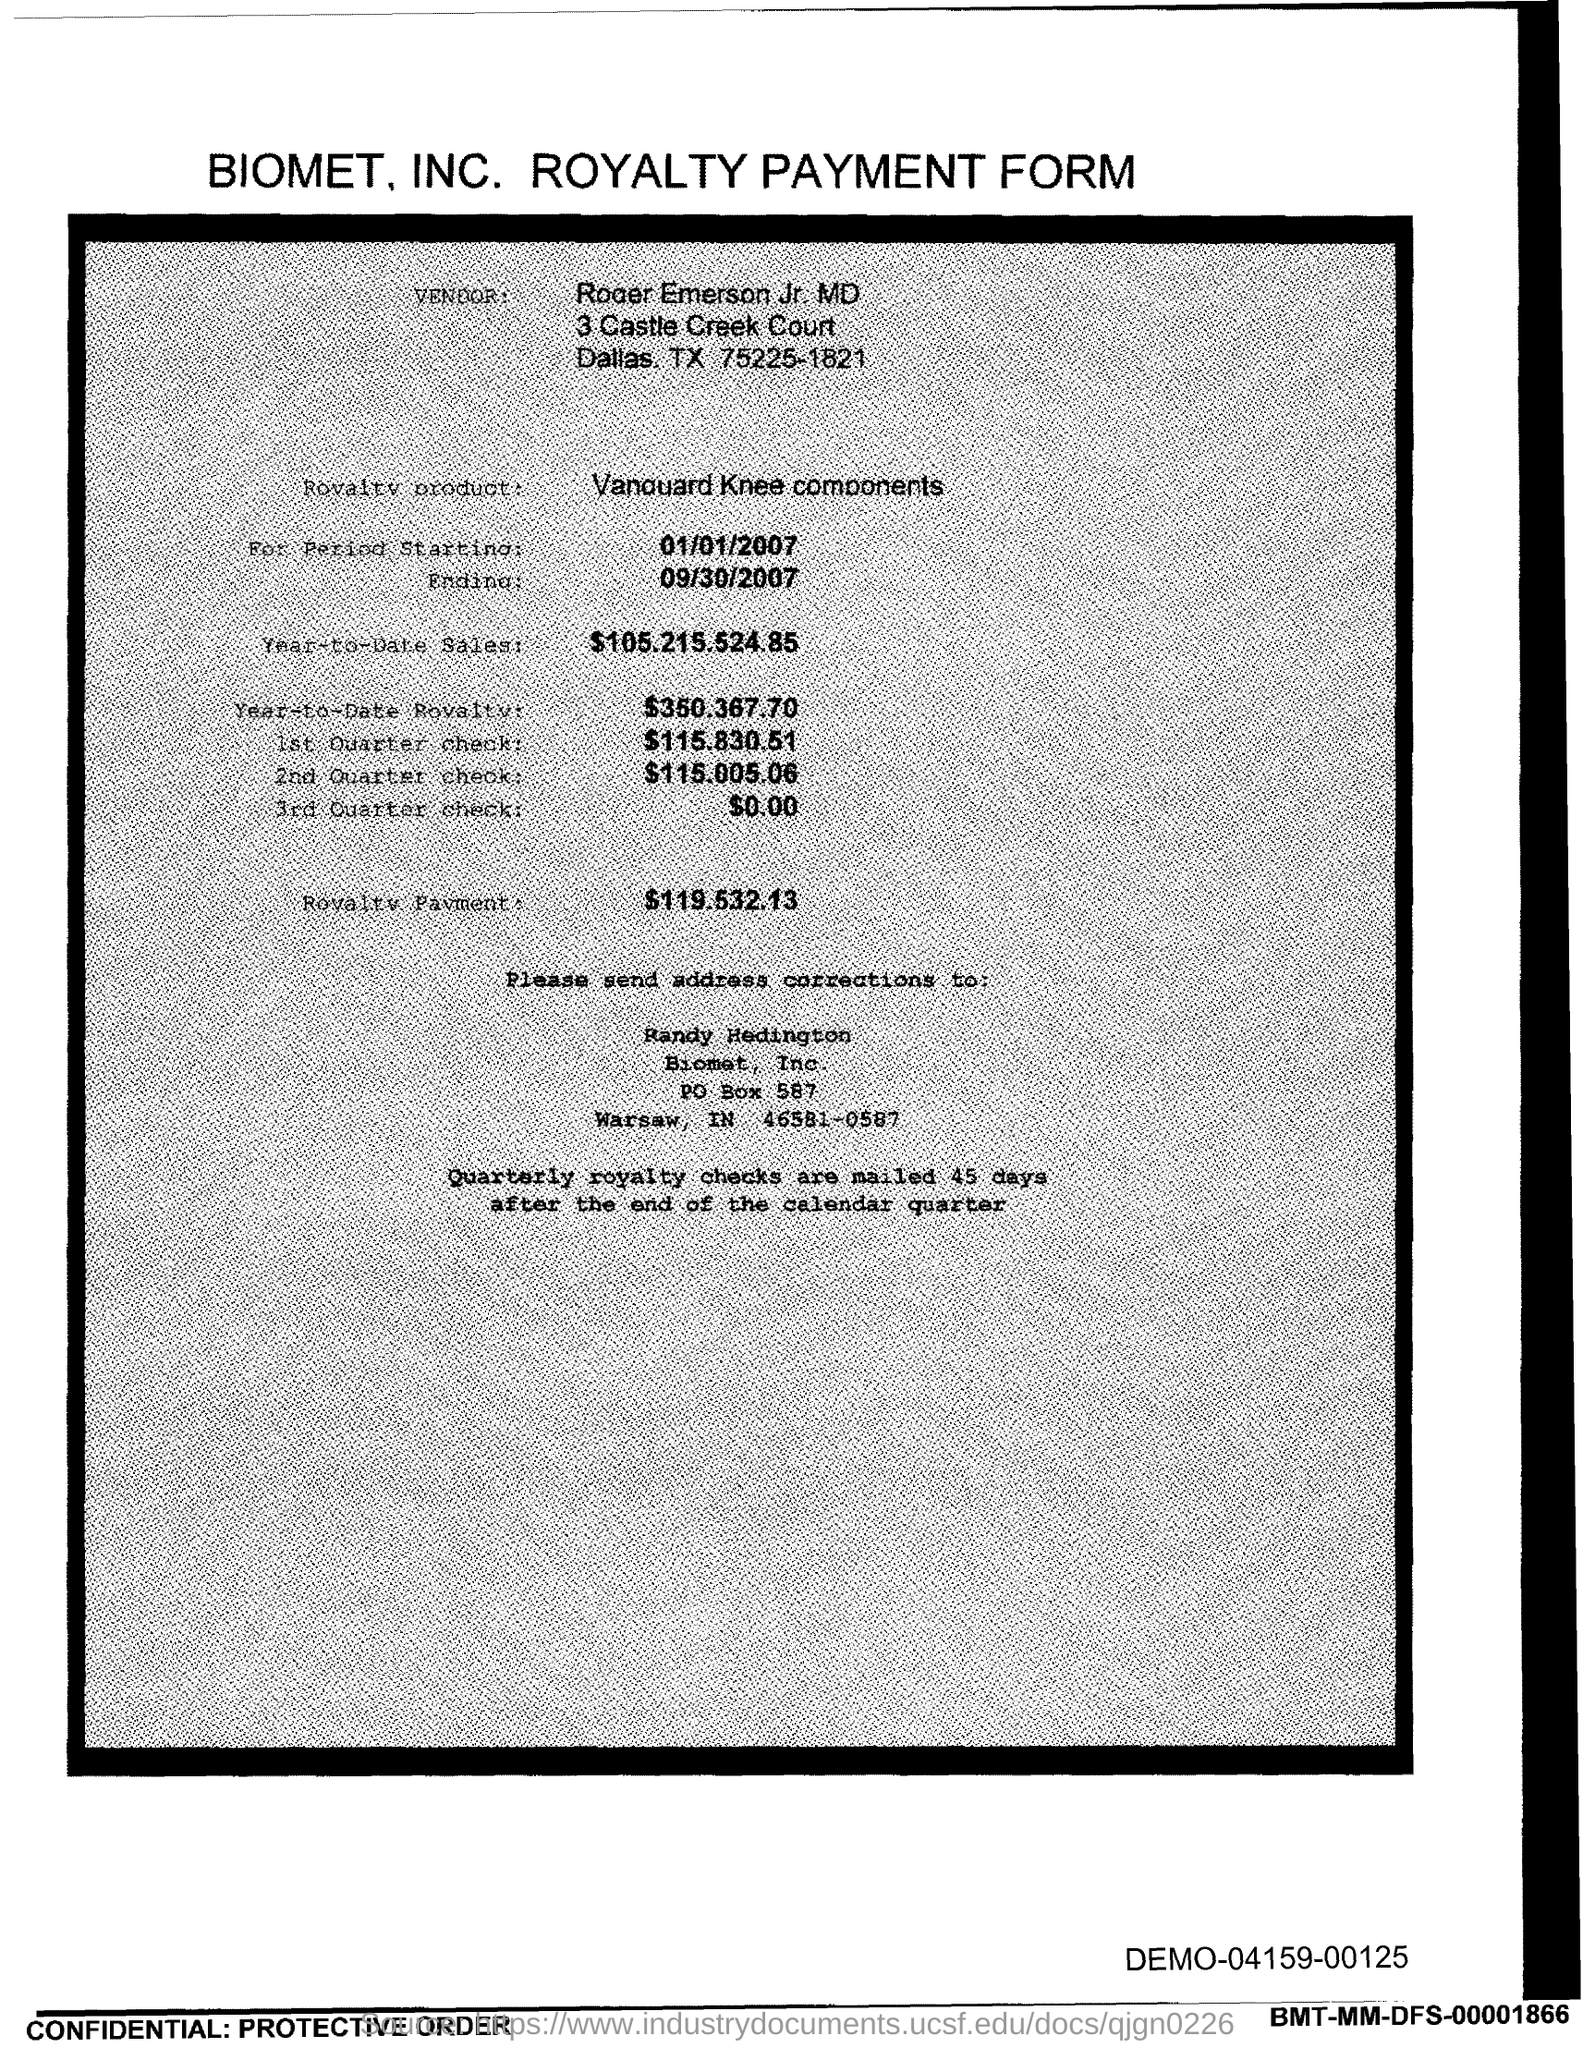Give some essential details in this illustration. The PO Box number mentioned in the document is 587. 